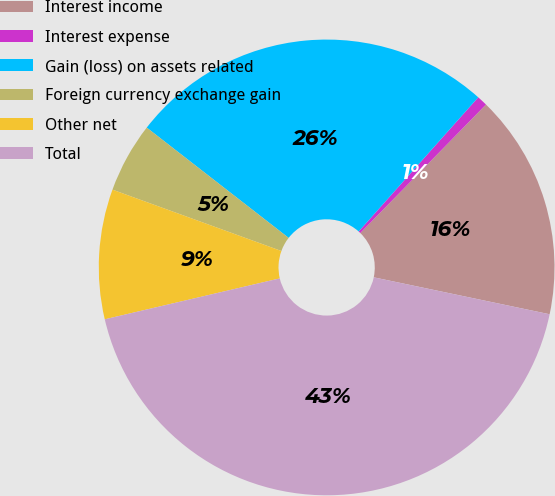<chart> <loc_0><loc_0><loc_500><loc_500><pie_chart><fcel>Interest income<fcel>Interest expense<fcel>Gain (loss) on assets related<fcel>Foreign currency exchange gain<fcel>Other net<fcel>Total<nl><fcel>15.97%<fcel>0.74%<fcel>26.07%<fcel>4.97%<fcel>9.2%<fcel>43.05%<nl></chart> 